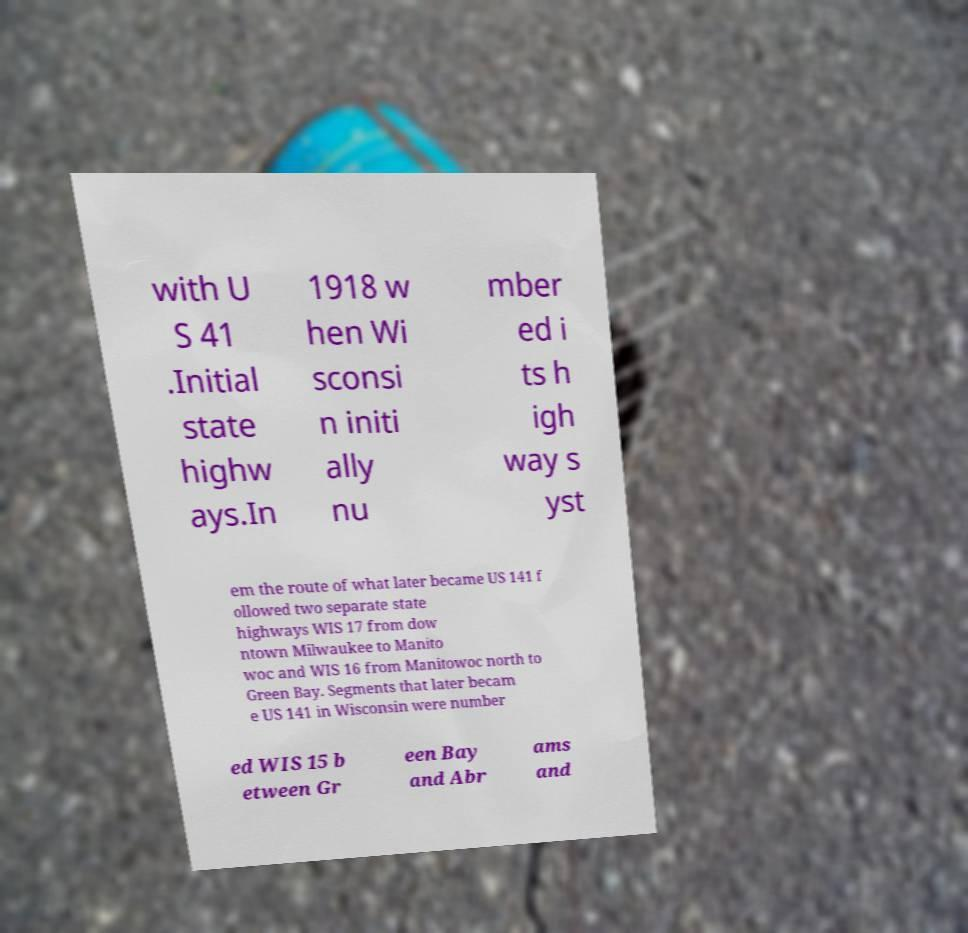Please read and relay the text visible in this image. What does it say? with U S 41 .Initial state highw ays.In 1918 w hen Wi sconsi n initi ally nu mber ed i ts h igh way s yst em the route of what later became US 141 f ollowed two separate state highways WIS 17 from dow ntown Milwaukee to Manito woc and WIS 16 from Manitowoc north to Green Bay. Segments that later becam e US 141 in Wisconsin were number ed WIS 15 b etween Gr een Bay and Abr ams and 